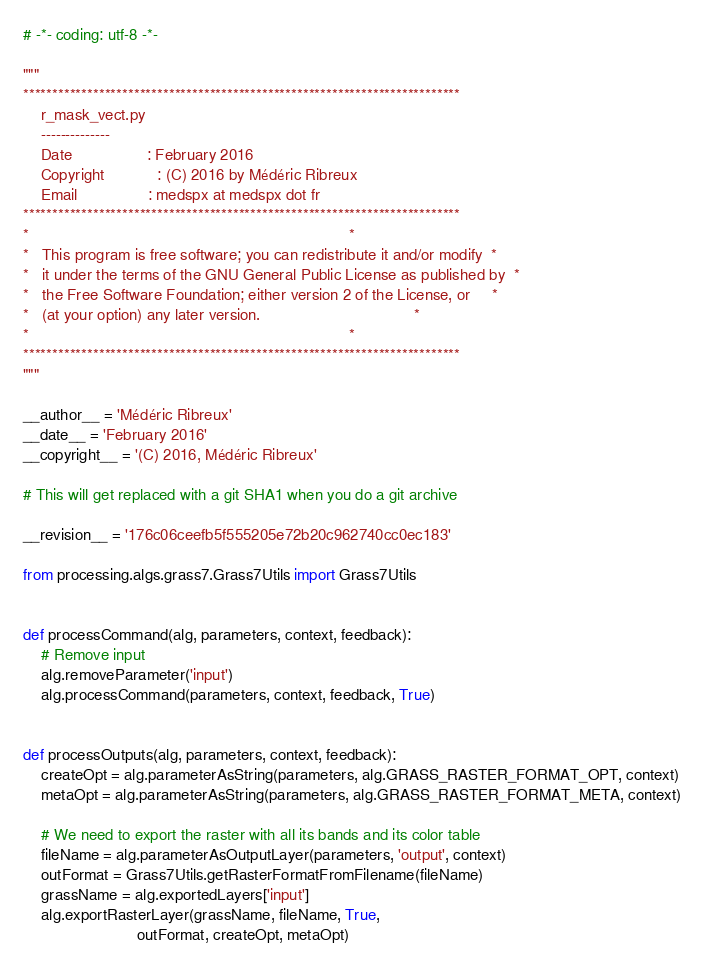<code> <loc_0><loc_0><loc_500><loc_500><_Python_># -*- coding: utf-8 -*-

"""
***************************************************************************
    r_mask_vect.py
    --------------
    Date                 : February 2016
    Copyright            : (C) 2016 by Médéric Ribreux
    Email                : medspx at medspx dot fr
***************************************************************************
*                                                                         *
*   This program is free software; you can redistribute it and/or modify  *
*   it under the terms of the GNU General Public License as published by  *
*   the Free Software Foundation; either version 2 of the License, or     *
*   (at your option) any later version.                                   *
*                                                                         *
***************************************************************************
"""

__author__ = 'Médéric Ribreux'
__date__ = 'February 2016'
__copyright__ = '(C) 2016, Médéric Ribreux'

# This will get replaced with a git SHA1 when you do a git archive

__revision__ = '176c06ceefb5f555205e72b20c962740cc0ec183'

from processing.algs.grass7.Grass7Utils import Grass7Utils


def processCommand(alg, parameters, context, feedback):
    # Remove input
    alg.removeParameter('input')
    alg.processCommand(parameters, context, feedback, True)


def processOutputs(alg, parameters, context, feedback):
    createOpt = alg.parameterAsString(parameters, alg.GRASS_RASTER_FORMAT_OPT, context)
    metaOpt = alg.parameterAsString(parameters, alg.GRASS_RASTER_FORMAT_META, context)

    # We need to export the raster with all its bands and its color table
    fileName = alg.parameterAsOutputLayer(parameters, 'output', context)
    outFormat = Grass7Utils.getRasterFormatFromFilename(fileName)
    grassName = alg.exportedLayers['input']
    alg.exportRasterLayer(grassName, fileName, True,
                          outFormat, createOpt, metaOpt)
</code> 